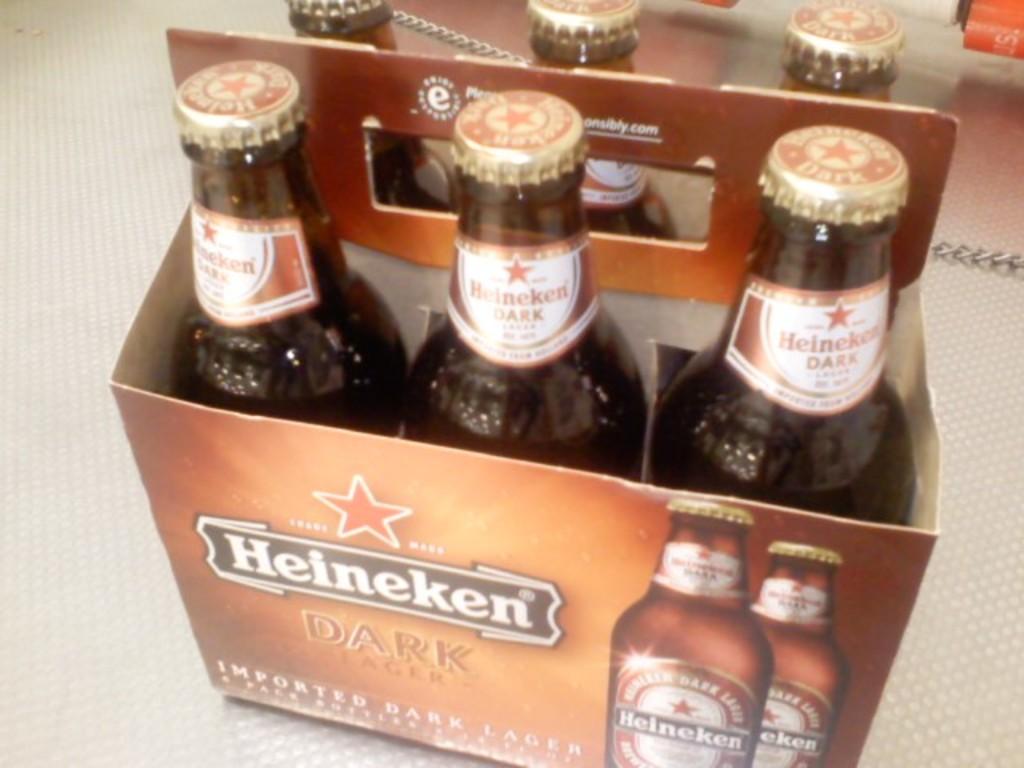Is this dark or light beer?
Offer a terse response. Dark. 